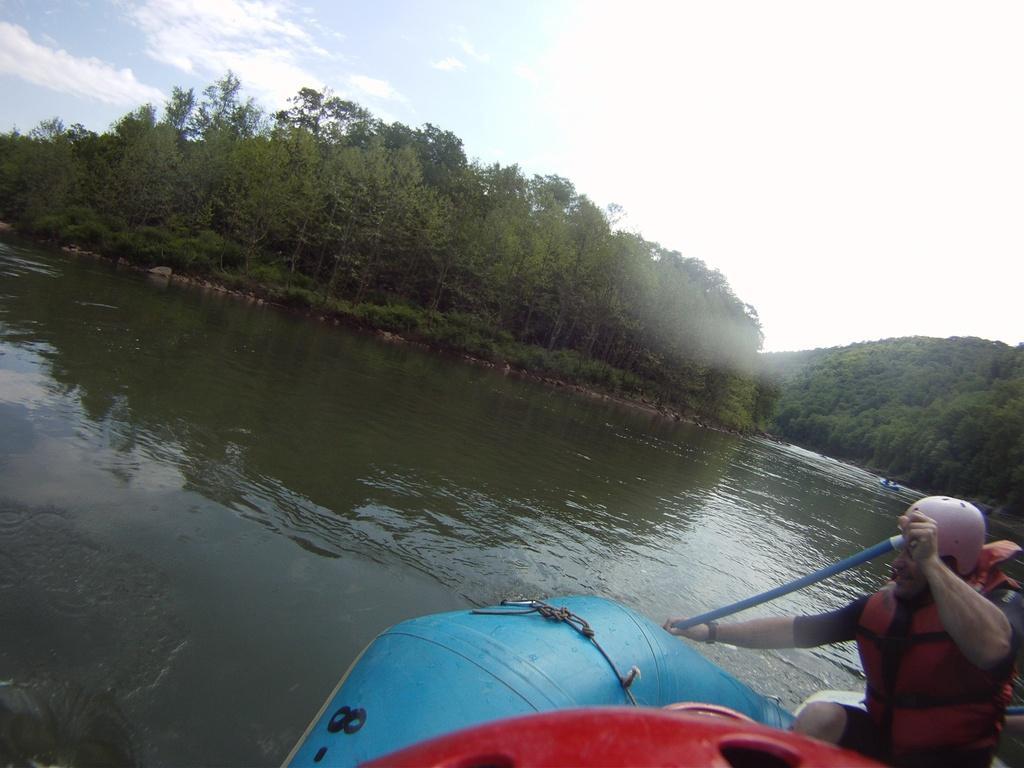In one or two sentences, can you explain what this image depicts? On the right side, there is a person in a boat which on the water. In the background, there are trees, plants, a mountain and there are clouds in the sky. 